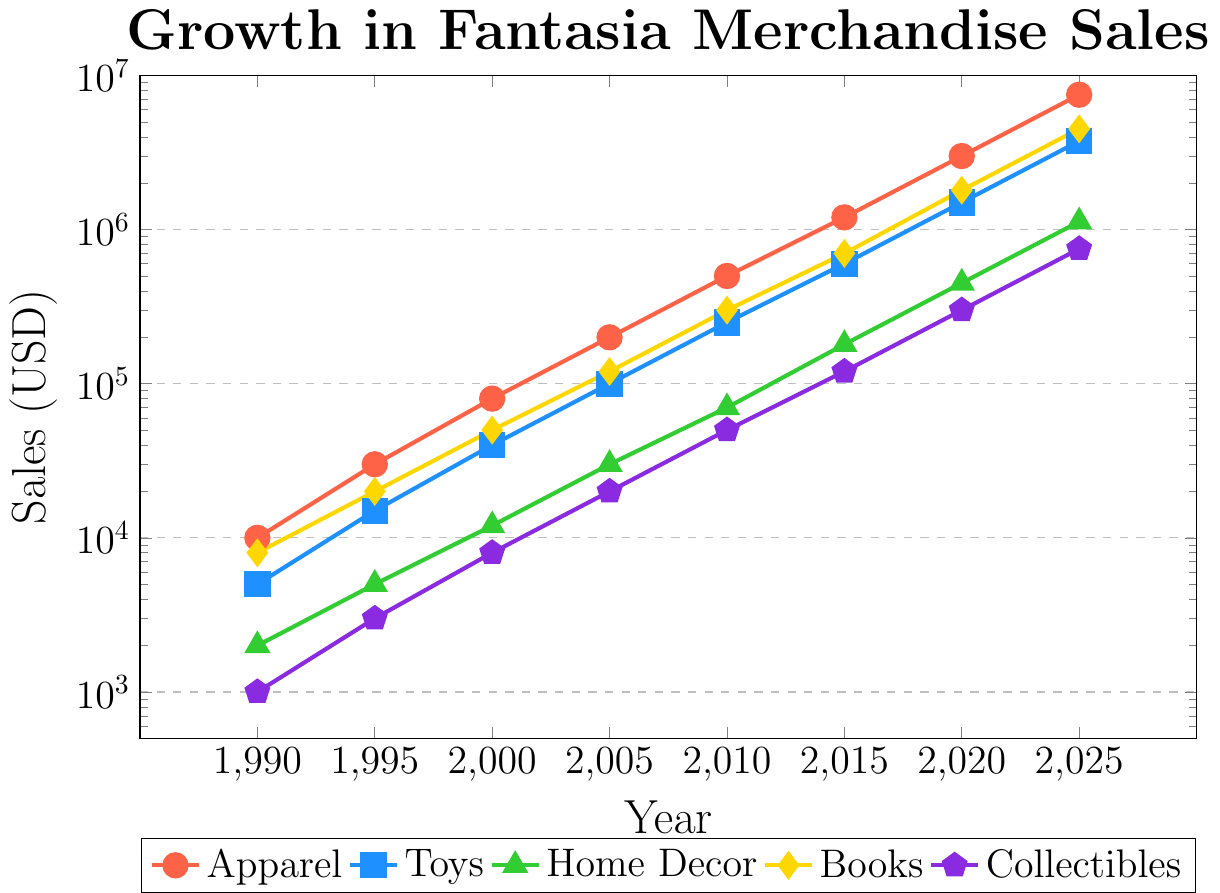Which product category had the highest sales in 2020? By looking at the plot, the category with the highest value in 2020 is Apparel. The y-axis indicates the sales amount, and the highest point among the categories for 2020 is Apparel.
Answer: Apparel Between Toys and Books, which category showed greater growth from 1990 to 2025? For Toys: 3750000 - 5000 = 3745000, for Books: 4500000 - 8000 = 4492000. Comparing 3745000 (Toys) and 4492000 (Books), Books had a greater growth.
Answer: Books What is the median sales value for Home Decor from 1990 to 2025? The sales values for Home Decor are 2000, 5000, 12000, 30000, 70000, 180000, 450000, 1125000. Arranging them in ascending order: 2000, 5000, 12000, 30000, 70000, 180000, 450000, 1125000. The median is the average of the 4th and 5th values: (30000 + 70000)/2 = 50000
Answer: 50000 By how much did Apparel sales increase between 2000 and 2015? The sales for Apparel in 2000 are 80000 and in 2015 are 1200000. The increase is 1200000 - 80000 = 1120000.
Answer: 1120000 What is the difference between the highest and lowest sales values for Collectibles from 1990 to 2025? The sales range for Collectibles is from 1000 in 1990 to 750000 in 2025. The difference is 750000 - 1000 = 749000.
Answer: 749000 Based on the plot, did any category have a sales value below 100,000 USD in 2015? Home Decor and Collectibles had sales values below 100,000 USD in 2015. As per the y-axis, both categories are below the 100,000 mark.
Answer: Yes Comparing the sales growth trajectories of Toys and Home Decor, which one had steeper growth between 2010 and 2020? For Toys: 1500000 - 250000 = 1250000, for Home Decor: 450000 - 70000 = 380000. Toys had a steeper growth as 1250000 > 380000.
Answer: Toys What percentage increase in sales did Books experience from 1995 to 2010? The sales of Books in 1995 are 20000 and in 2010 are 300000. The percentage increase is ((300000 - 20000) / 20000) * 100 = 1400%.
Answer: 1400% Which year saw the highest sales growth for Collectibles? Comparing the growth between each consecutive year for Collectibles: 3000 (1995-1990), 5000 (2000-1995), 12000 (2005-2000), 30000 (2010-2005), 70000 (2015-2010), 180000 (2020-2015), 450000 (2025-2020). The highest growth was from 2015 to 2020, with a difference of 180000.
Answer: Between 2015 and 2020 